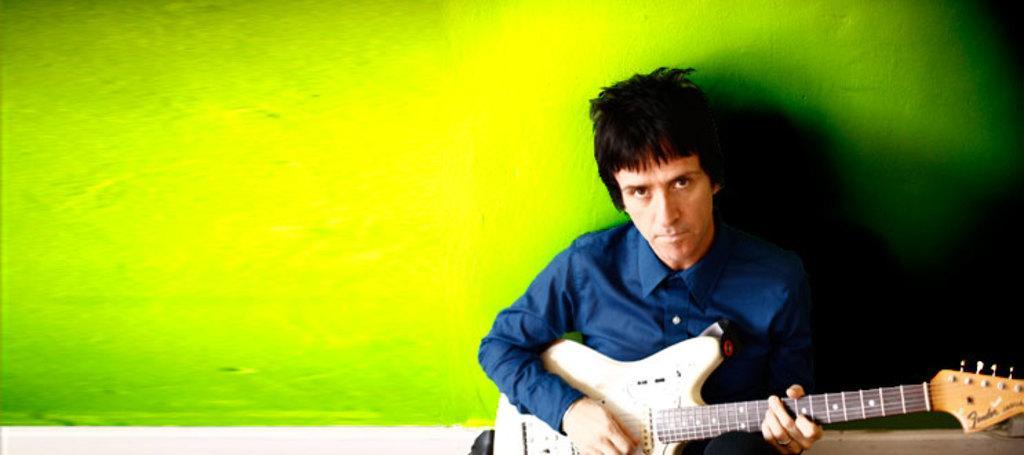Can you describe this image briefly? This man is holding a guitar and he wore blue shirt. 